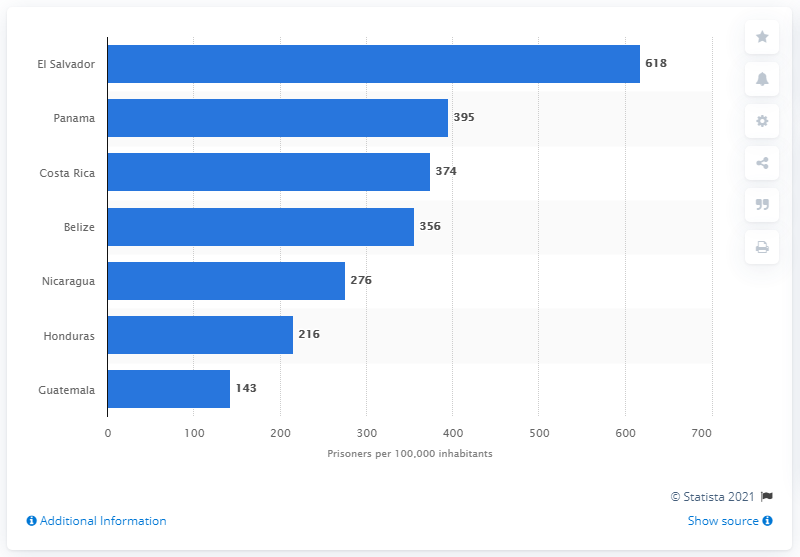Draw attention to some important aspects in this diagram. According to data, Panama has the highest prison population rate among all Central American nations. El Salvador has the highest prison population rate among Central American nations. 